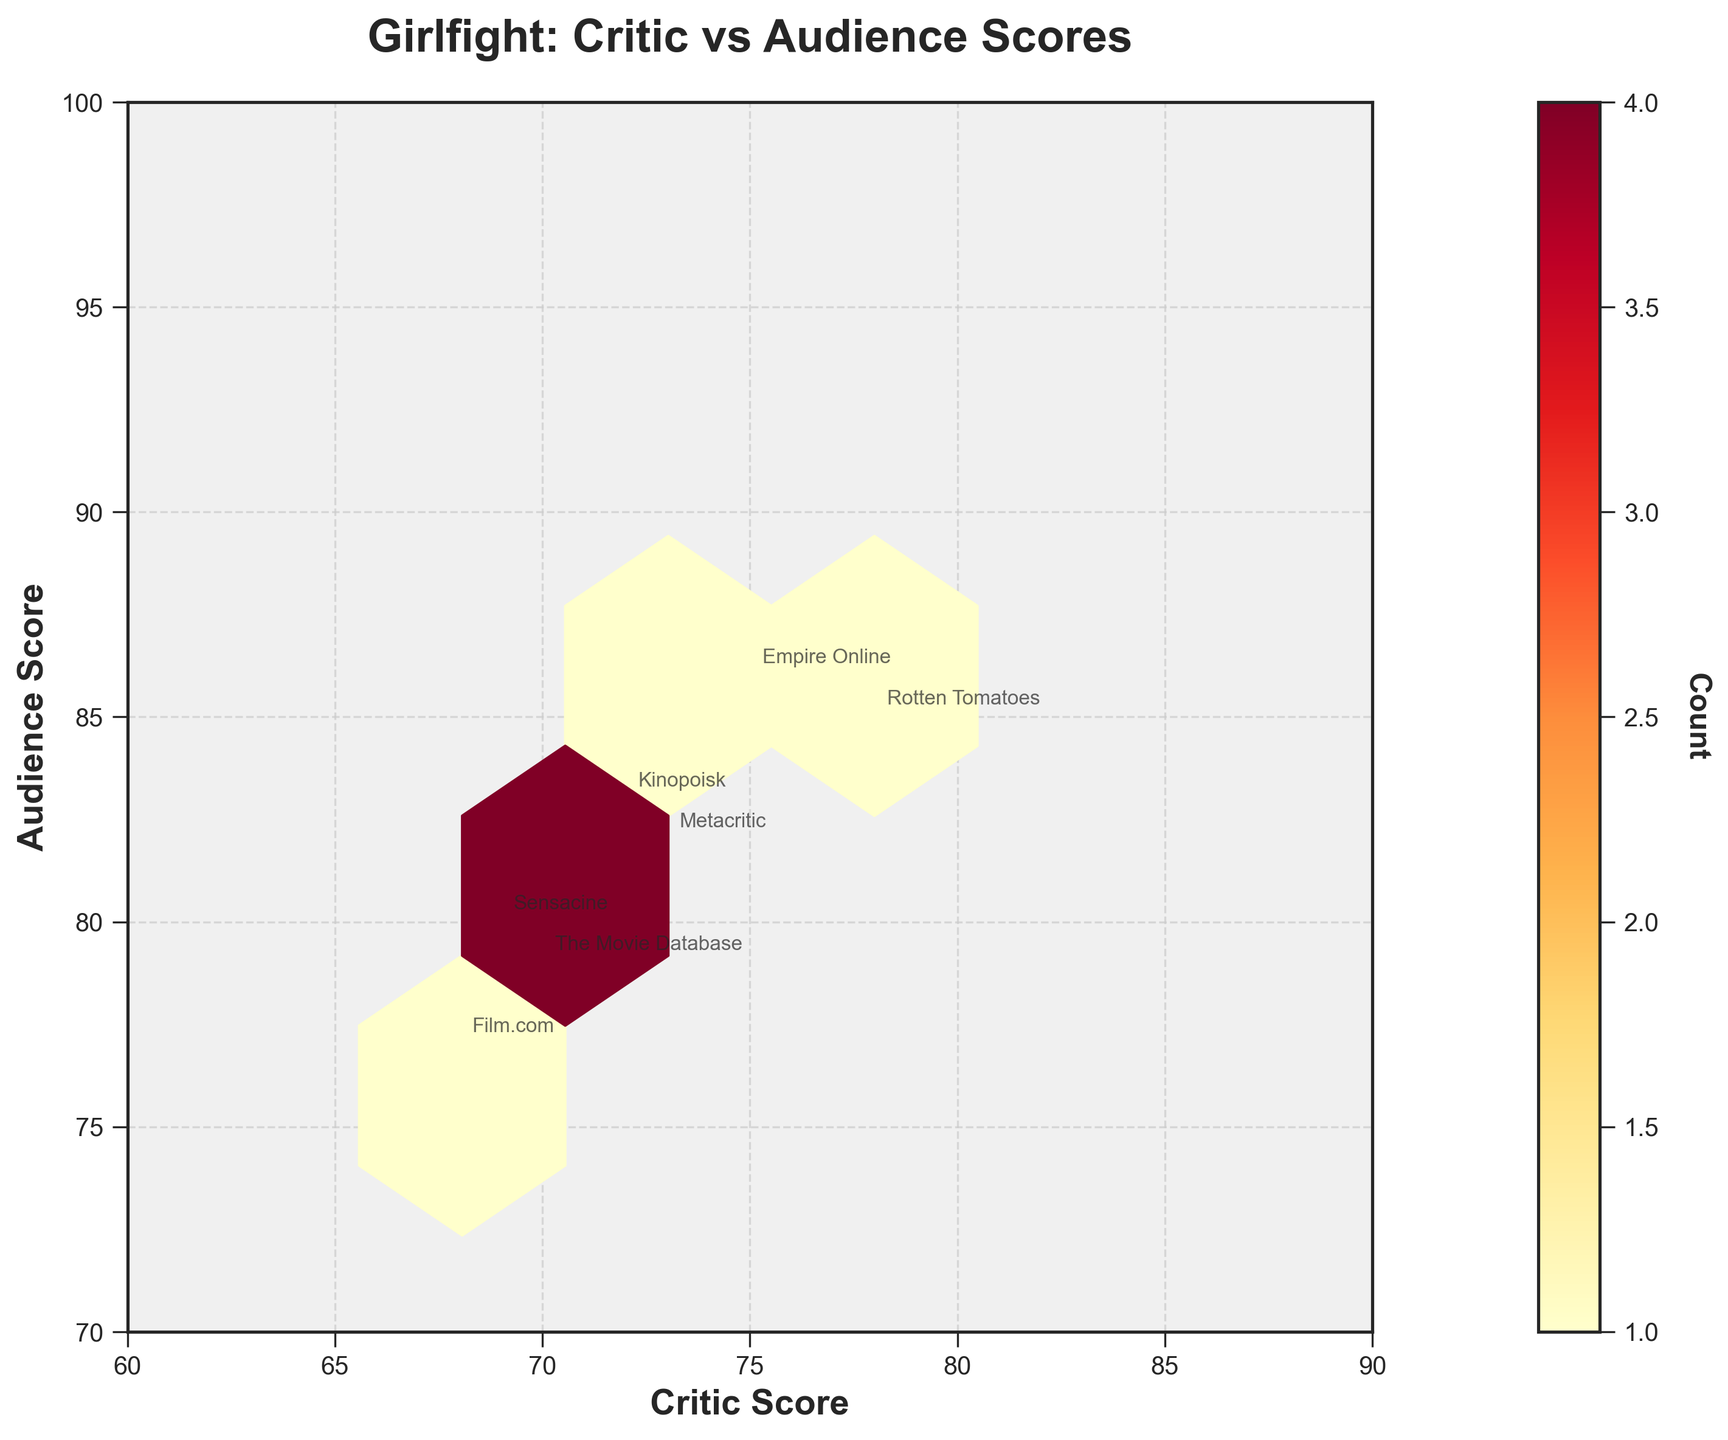How many data points show both Critic and Audience scores greater than 80? To find this, visualize the hexbin plot and identify the hexagons in the region where both axes are greater than 80. Since each hexagon represents a count of data points, we sum the counts for these hexagons.
Answer: 3 Which review site has the highest discrepancy between Critic and Audience scores? Calculate the difference between Critic and Audience scores for each review site shown on the plot. Look for the site with the largest absolute difference.
Answer: AllMovie (difference of 7) What's the mean Critic score across all review sites represented in the plot? Add all the Critic scores and divide by the number of review sites. The scores are: (78 + 7.2 + 73 + 3.5 + 7.5 + 70 + 3.8 + 75 + 7.3 + 68 + 3.6 + 72 + 7.0 + 69 + 3.7).
Answer: 33.33 What is the range of Audience scores displayed in the plot? Identify the minimum and maximum values on the Audience Score axis from the data points annotated and subtract the minimum from the maximum.
Answer: 69 - 86 Which score type (Critic or Audience) shows a higher overall variance in the plot? Calculate the variance for both Critic and Audience scores separately using the squared deviations from their respective means. Compare the two variance values to determine which is higher.
Answer: Audience scores On which review site do the Critic and Audience scores show the closest values? Review the differences between Critic and Audience scores for each site and identify the smallest difference.
Answer: IMDb (0.6) How many review sites have both Critic and Audience scores below 80? Identify the hexagons in the hexbin plot where values on both axes are below 80. Count the total number of review sites in these hexagons.
Answer: 7 Which review site has the highest Audience score and what is that score? Look for the highest point on the Audience Score axis among the annotated points on the plot and identify the corresponding review site.
Answer: Empire Online (86) What color scheme is used in the hexbin plot to indicate different count levels? Note the provided color map for the hexbin plot, which in this case, uses shades from a specific palette to indicate count levels.
Answer: Yellows and reds (YlOrRd) 